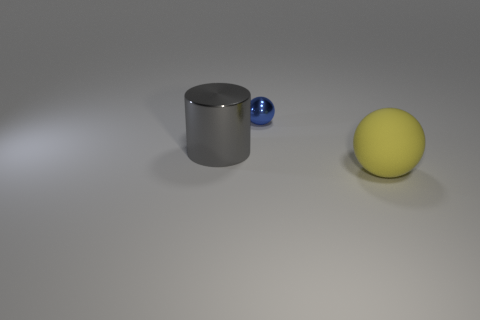There is a thing that is behind the big gray metallic cylinder; is its size the same as the ball that is in front of the small metallic object?
Your answer should be very brief. No. Is the number of rubber objects that are on the right side of the rubber thing less than the number of large balls to the left of the big gray shiny cylinder?
Keep it short and to the point. No. There is a shiny thing that is right of the metallic cylinder; what is its color?
Ensure brevity in your answer.  Blue. Is the color of the large matte object the same as the big cylinder?
Make the answer very short. No. There is a big object that is right of the ball left of the yellow object; how many objects are in front of it?
Provide a short and direct response. 0. What is the size of the yellow sphere?
Your response must be concise. Large. What is the material of the other thing that is the same size as the yellow object?
Your answer should be compact. Metal. There is a small blue sphere; what number of large gray cylinders are in front of it?
Provide a succinct answer. 1. Do the large object that is behind the yellow rubber sphere and the ball behind the yellow rubber object have the same material?
Your answer should be very brief. Yes. The big object that is to the left of the sphere that is on the right side of the metallic thing that is on the right side of the metal cylinder is what shape?
Provide a succinct answer. Cylinder. 